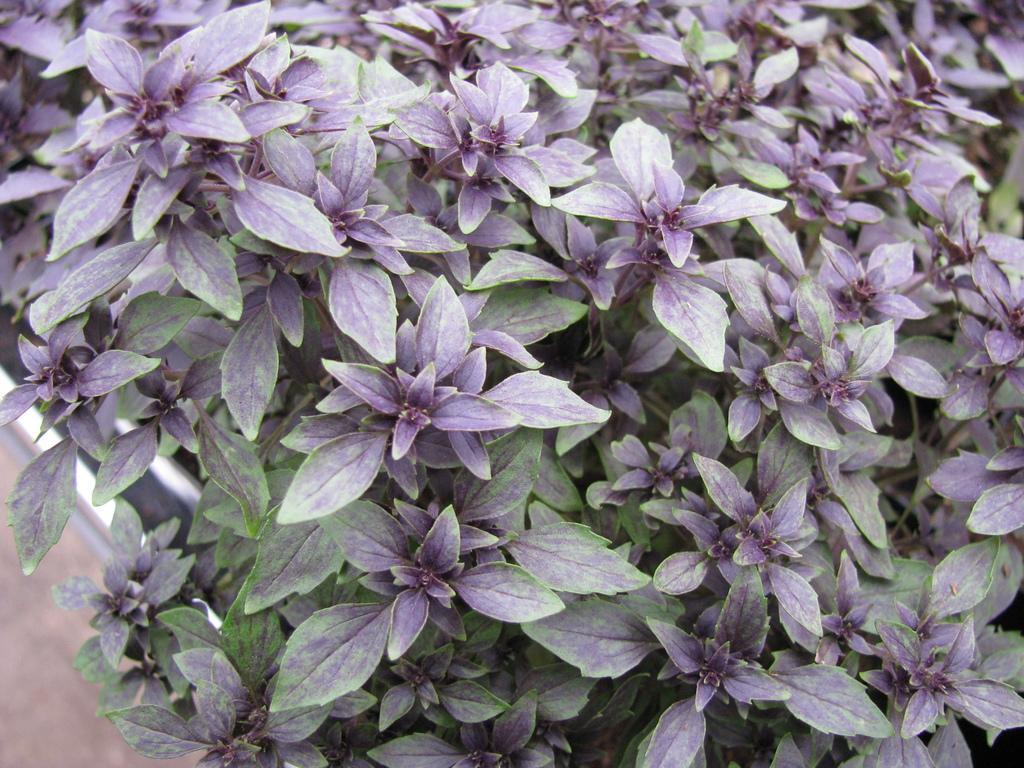In one or two sentences, can you explain what this image depicts? In this image we can see flowers. 